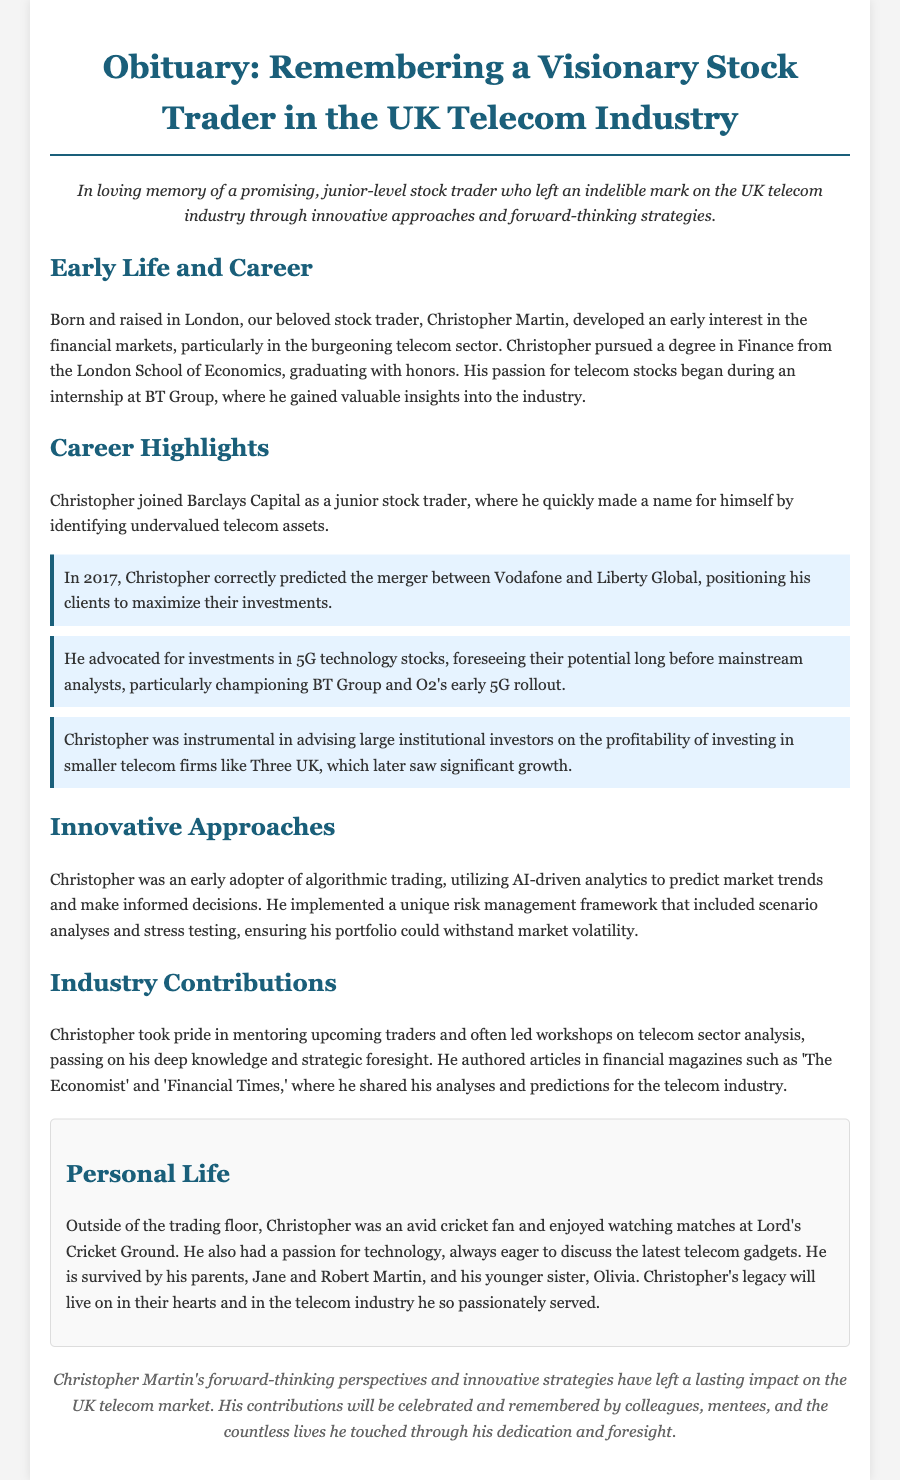what was Christopher Martin's degree? The document states Christopher graduated with a degree in Finance from the London School of Economics.
Answer: Finance which company did Christopher intern at? The document mentions Christopher gained valuable insights during an internship at BT Group.
Answer: BT Group what significant event did Christopher predict in 2017? The obituary highlights Christopher's prediction of the merger between Vodafone and Liberty Global in 2017.
Answer: merger between Vodafone and Liberty Global how did Christopher utilize technology in trading? The document notes Christopher was an early adopter of algorithmic trading, using AI-driven analytics.
Answer: algorithmic trading what was one of Christopher's contributions to the industry? The obituary states Christopher led workshops on telecom sector analysis, mentoring upcoming traders.
Answer: mentoring upcoming traders who are Christopher's surviving family members? The document lists his parents, Jane and Robert Martin, and his younger sister, Olivia, as survivors.
Answer: Jane, Robert, and Olivia in which publications did Christopher author articles? The document specifies he authored articles in financial magazines such as 'The Economist' and 'Financial Times.'
Answer: The Economist and Financial Times what was Christopher's passion outside of trading? The obituary describes Christopher as an avid cricket fan, enjoying matches at Lord's.
Answer: cricket what innovative framework did Christopher implement? The document mentions he implemented a unique risk management framework including scenario analyses and stress testing.
Answer: risk management framework 